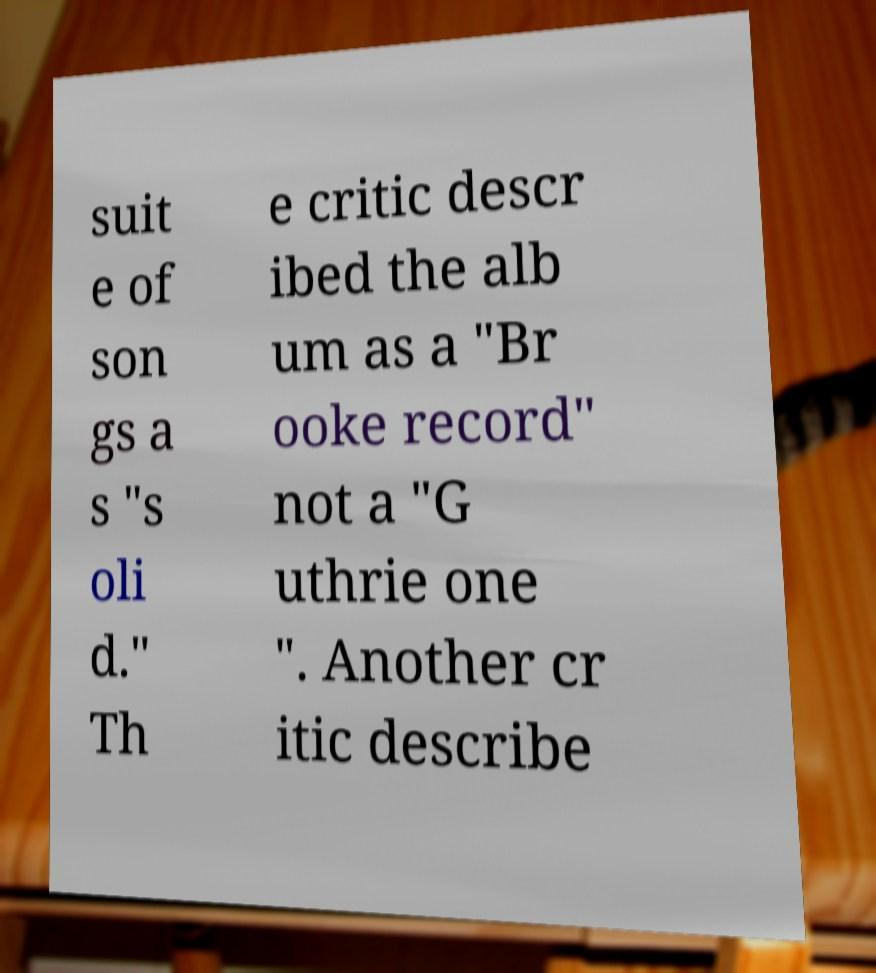I need the written content from this picture converted into text. Can you do that? suit e of son gs a s "s oli d." Th e critic descr ibed the alb um as a "Br ooke record" not a "G uthrie one ". Another cr itic describe 